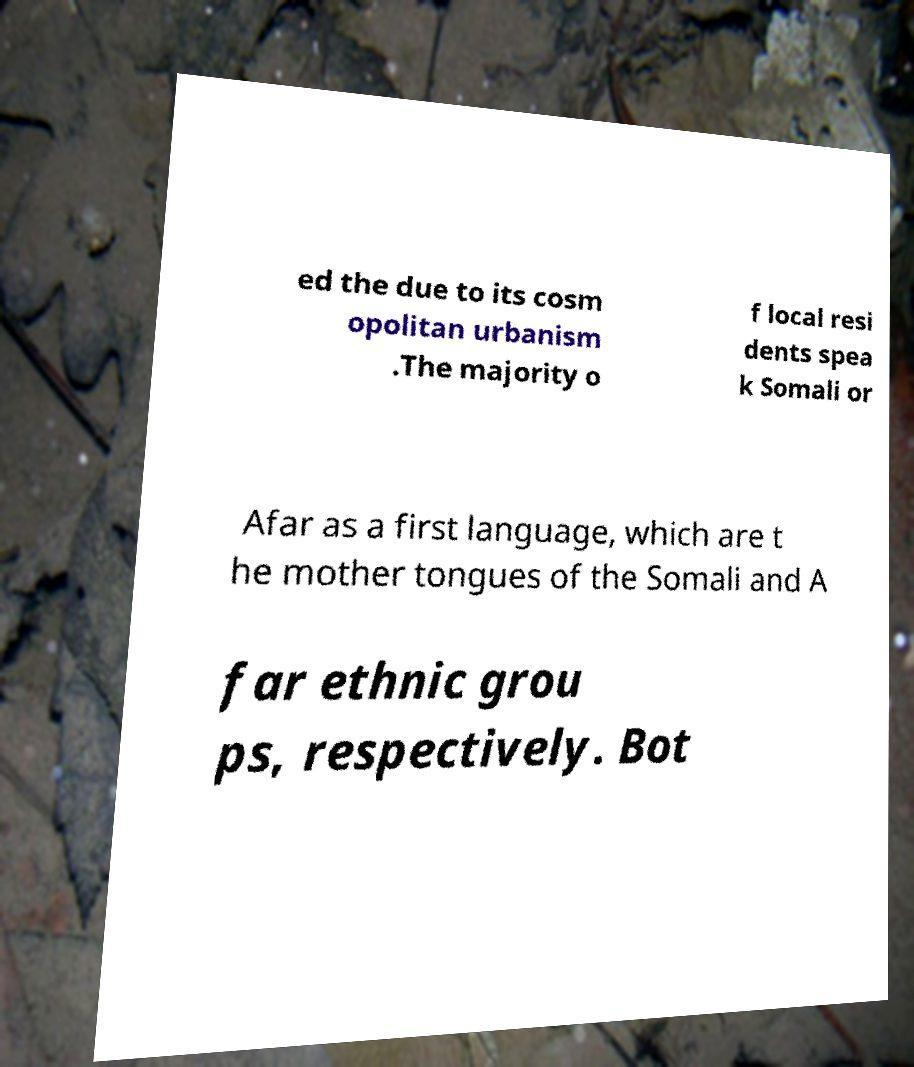Can you accurately transcribe the text from the provided image for me? ed the due to its cosm opolitan urbanism .The majority o f local resi dents spea k Somali or Afar as a first language, which are t he mother tongues of the Somali and A far ethnic grou ps, respectively. Bot 